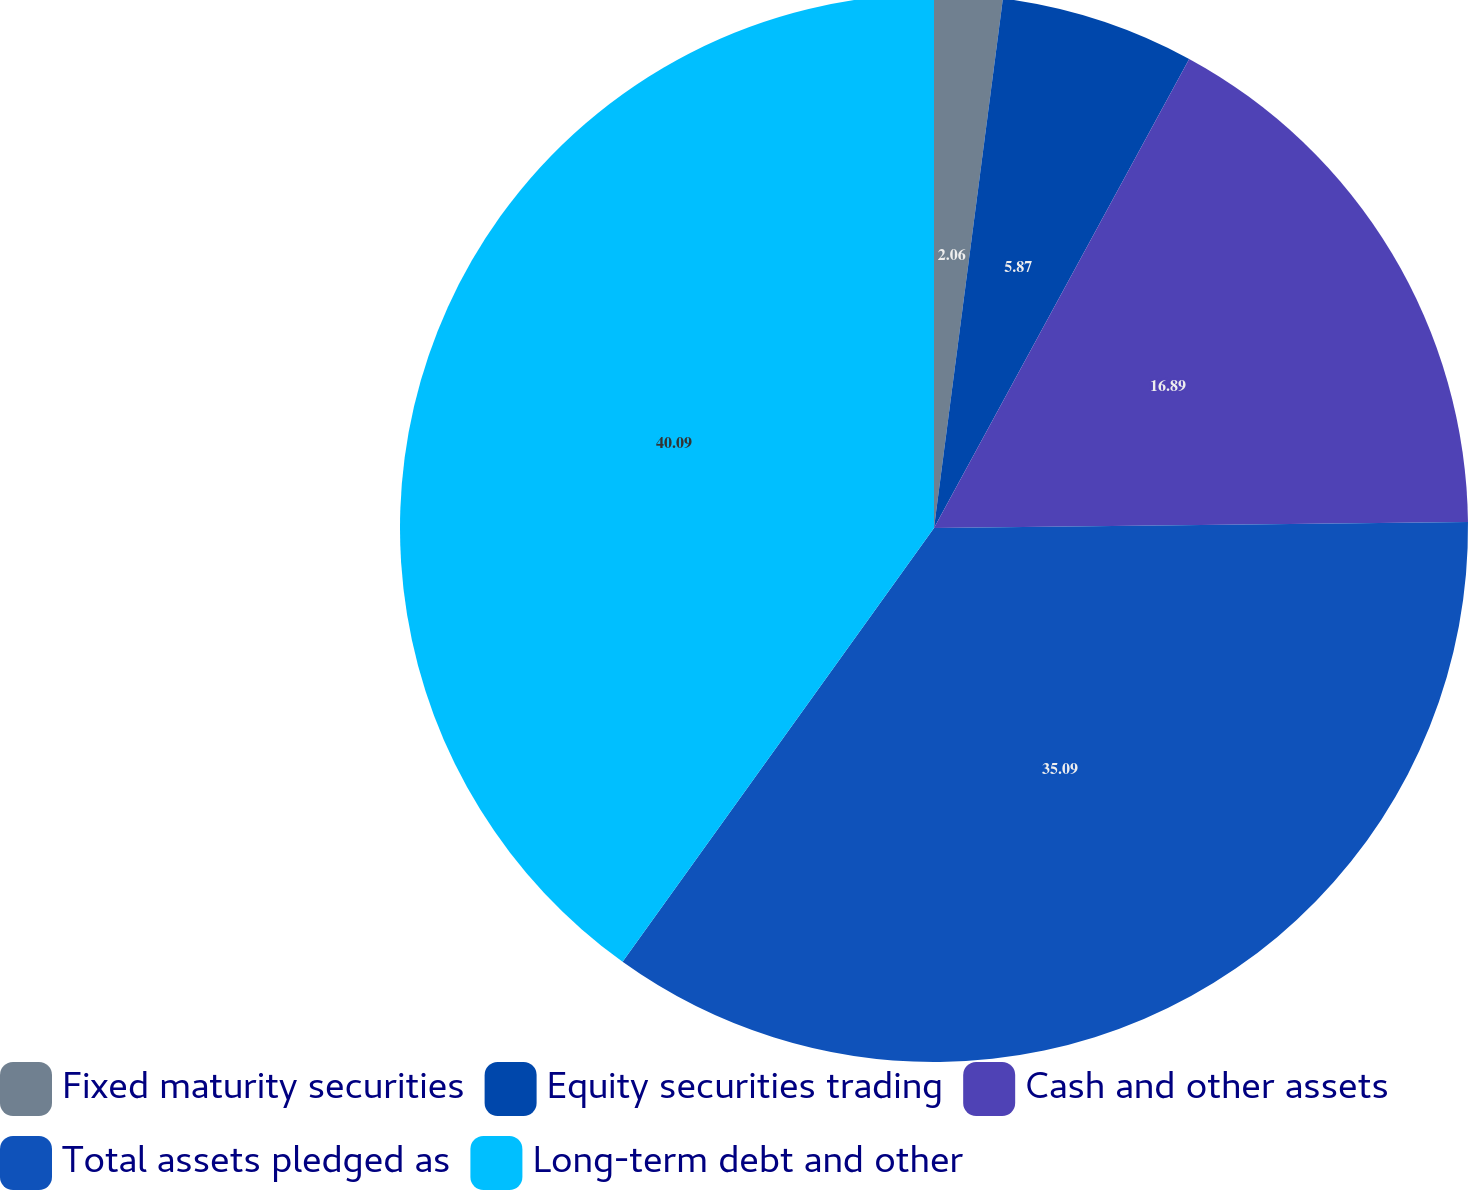<chart> <loc_0><loc_0><loc_500><loc_500><pie_chart><fcel>Fixed maturity securities<fcel>Equity securities trading<fcel>Cash and other assets<fcel>Total assets pledged as<fcel>Long-term debt and other<nl><fcel>2.06%<fcel>5.87%<fcel>16.89%<fcel>35.09%<fcel>40.09%<nl></chart> 